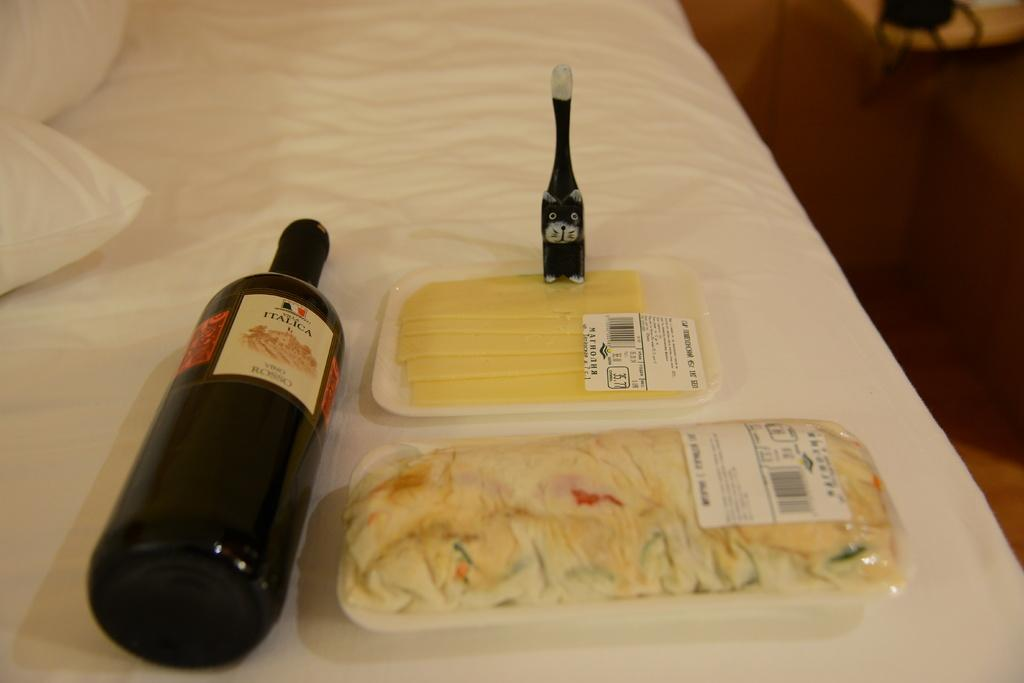What is the main object in the foreground of the picture? There is a bed in the foreground of the picture. What can be seen on the bed? There are pillows, a liquor bottle, food items, and other objects on the bed. Can you describe the condition of the right side of the image? The right side of the image is blurred. What type of bean is being used to make a mitten in the image? There is no bean or mitten present in the image. 